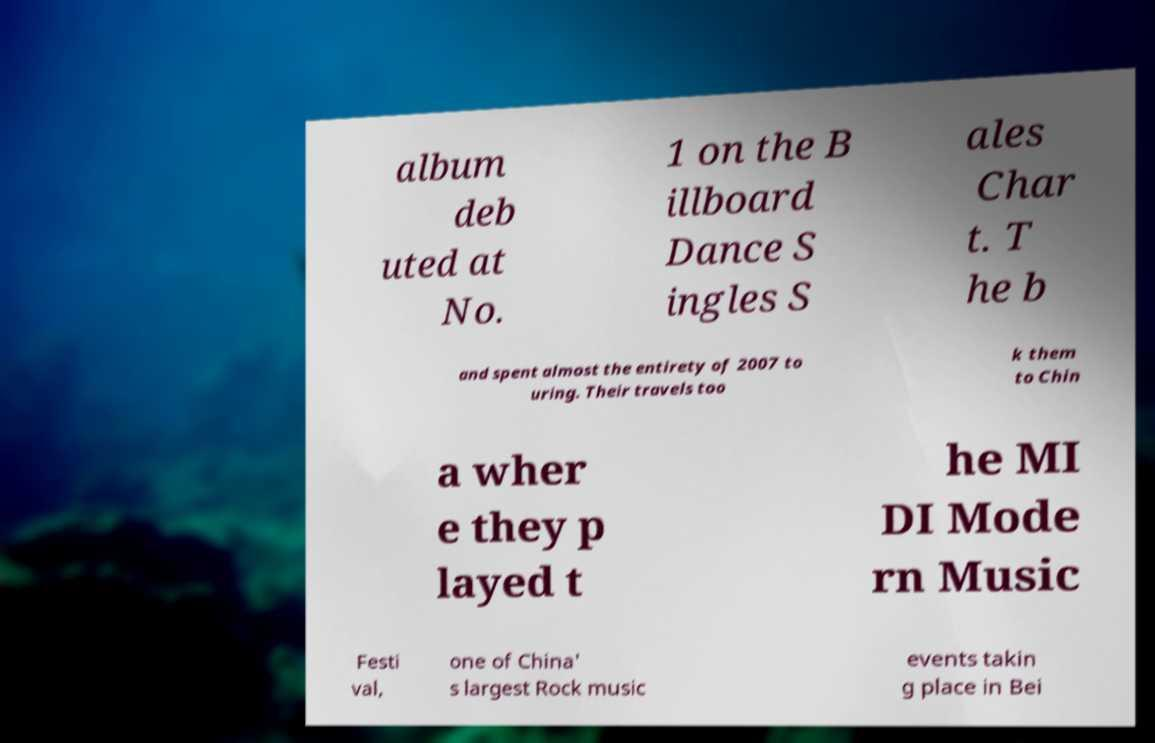There's text embedded in this image that I need extracted. Can you transcribe it verbatim? album deb uted at No. 1 on the B illboard Dance S ingles S ales Char t. T he b and spent almost the entirety of 2007 to uring. Their travels too k them to Chin a wher e they p layed t he MI DI Mode rn Music Festi val, one of China' s largest Rock music events takin g place in Bei 